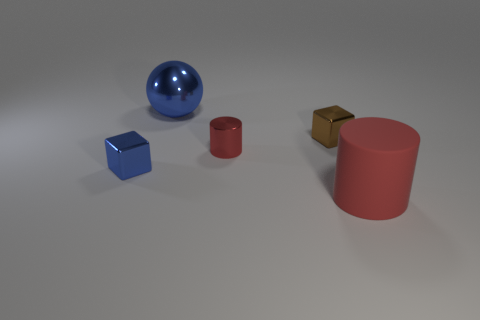What time of day does the lighting in the image suggest? The lighting in the image does not suggest any particular time of day as it appears to be a controlled, studio-like environment with diffused lighting that evenly illuminates the objects, likely from overhead sources without any strong directional shadows that would be indicative of a natural light source like the sun. 